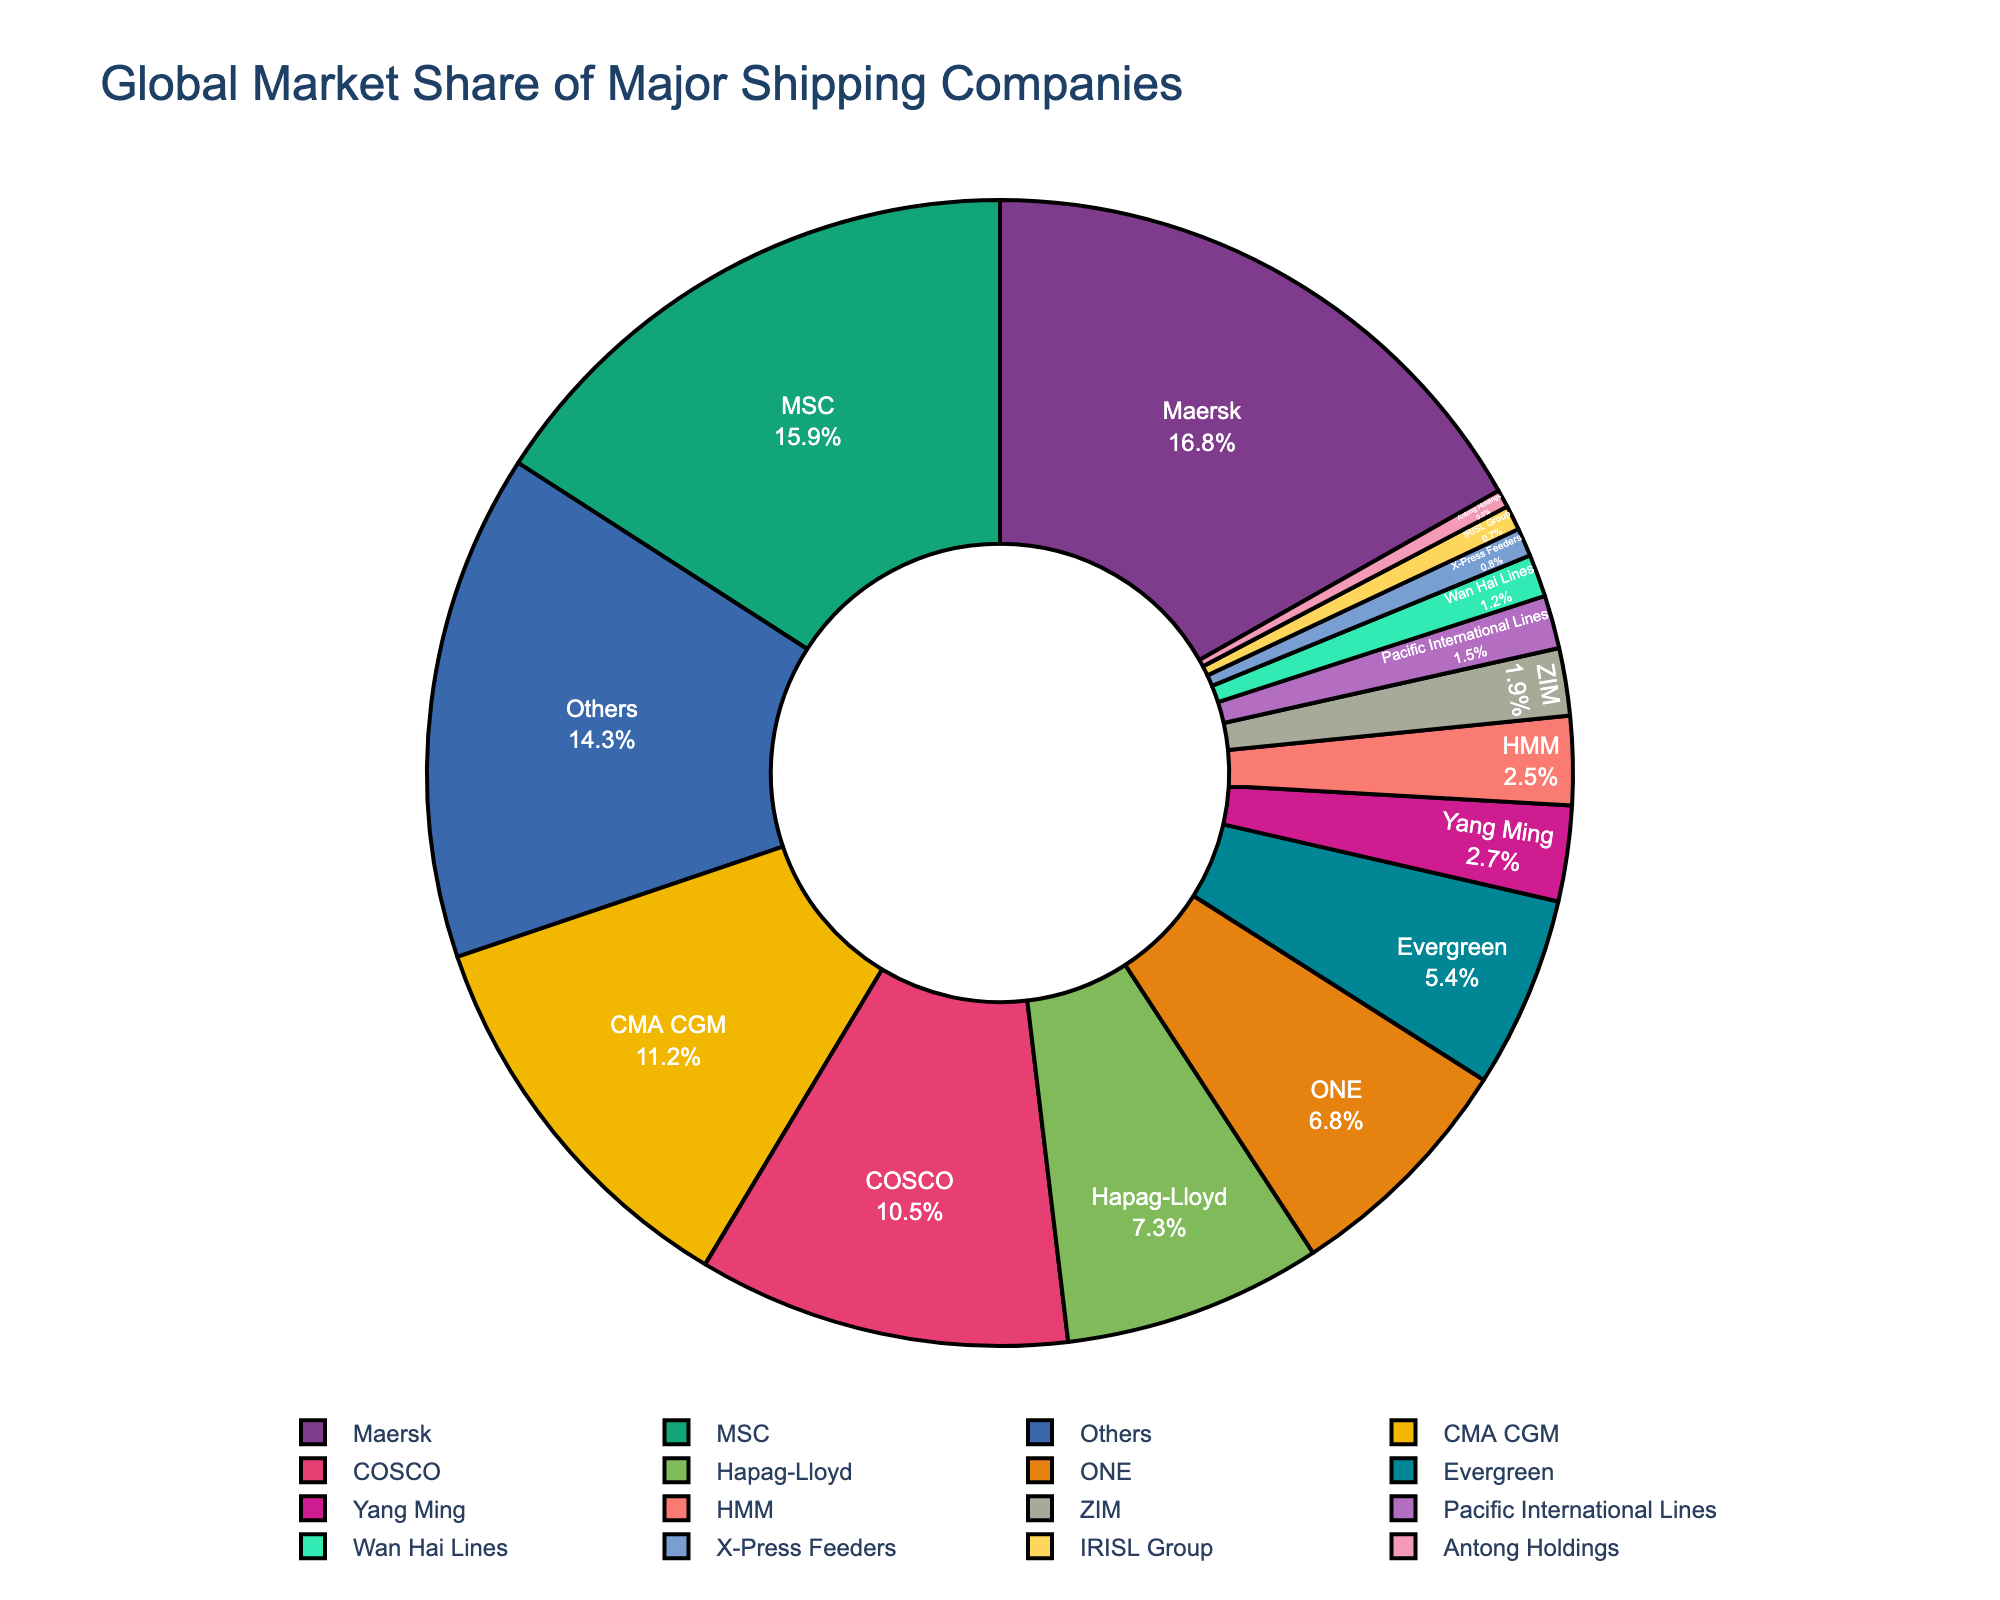What's the market share of the top three companies combined? The top three companies are Maersk (16.8%), MSC (15.9%), and CMA CGM (11.2%). Add their market shares: 16.8 + 15.9 + 11.2 = 43.9%.
Answer: 43.9% Which company has the smallest market share? The company with the smallest market share is Antong Holdings with 0.5%.
Answer: Antong Holdings How much larger is Maersk's market share compared to ZIM's market share? Maersk's market share is 16.8%, and ZIM's market share is 1.9%. The difference is 16.8 - 1.9 = 14.9%.
Answer: 14.9% What proportion of the market is held by companies with a market share below 5%? Companies with a market share below 5% are Evergreen (5.4%, excluded), Yang Ming (2.7%), HMM (2.5%), ZIM (1.9%), Pacific International Lines (1.5%), Wan Hai Lines (1.2%), X-Press Feeders (0.8%), IRISL Group (0.7%), and Antong Holdings (0.5%). Sum these values: 2.7 + 2.5 + 1.9 + 1.5 + 1.2 + 0.8 + 0.7 + 0.5 = 11.8%.
Answer: 11.8% Which two companies have a combined market share that exceeds 20%? Look at pairs of companies: Maersk (16.8%) + any company with more than 3.2% will meet the requirement. Maersk (16.8%) + MSC (15.9%) is one combination. Another is MSC (15.9%) + CMA CGM (11.2%). Several combinations exist, but these are the simplest.
Answer: Maersk and MSC, MSC and CMA CGM Are there more companies with a market share above 10% or below 10%? Companies with a market share above 10%: Maersk, MSC, CMA CGM, and COSCO (4 companies). Companies with a market share below 10%: Hapag-Lloyd, ONE, Evergreen, Yang Ming, HMM, ZIM, Pacific International Lines, Wan Hai Lines, X-Press Feeders, IRISL Group, Antong Holdings, and Others (12 entities). There are more companies below 10%.
Answer: Below 10% What percentage of the market do the companies outside the top 10 hold? The pie chart segment labeled "Others" represents 14.3% of the market.
Answer: 14.3% 